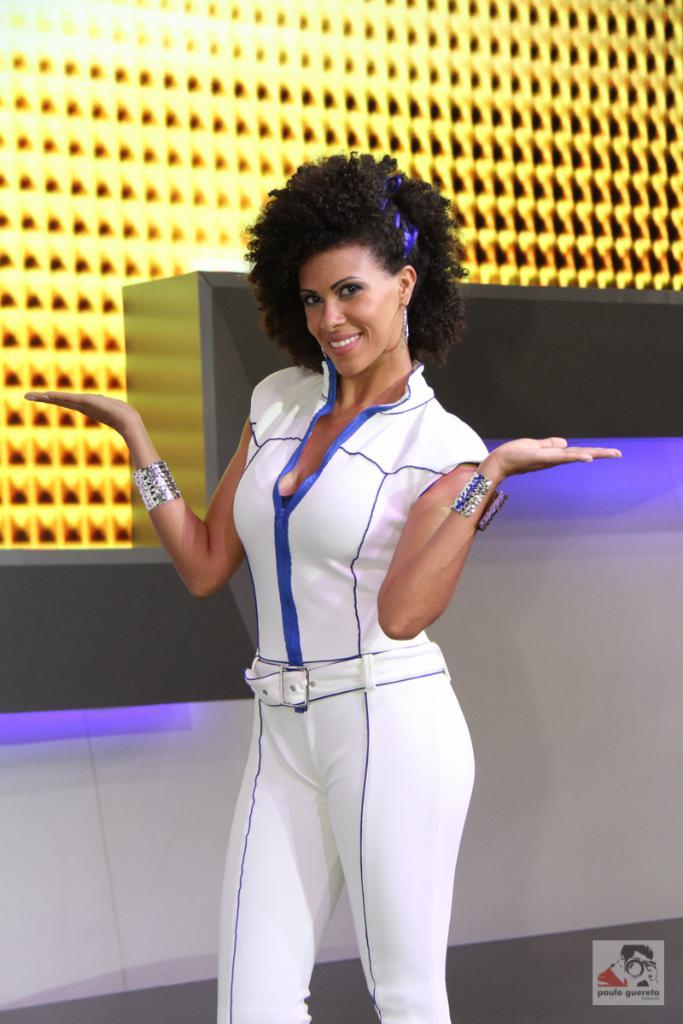Who is the main subject in the image? There is a lady standing in the center of the image. What is the lady wearing? The lady is wearing a white dress. What can be seen in the background of the image? There is a wall and lights visible in the background of the image. What type of pollution can be seen in the image? There is no pollution visible in the image. What kind of art is displayed on the wall in the image? The image does not show any art on the wall; it only shows a wall and lights in the background. 